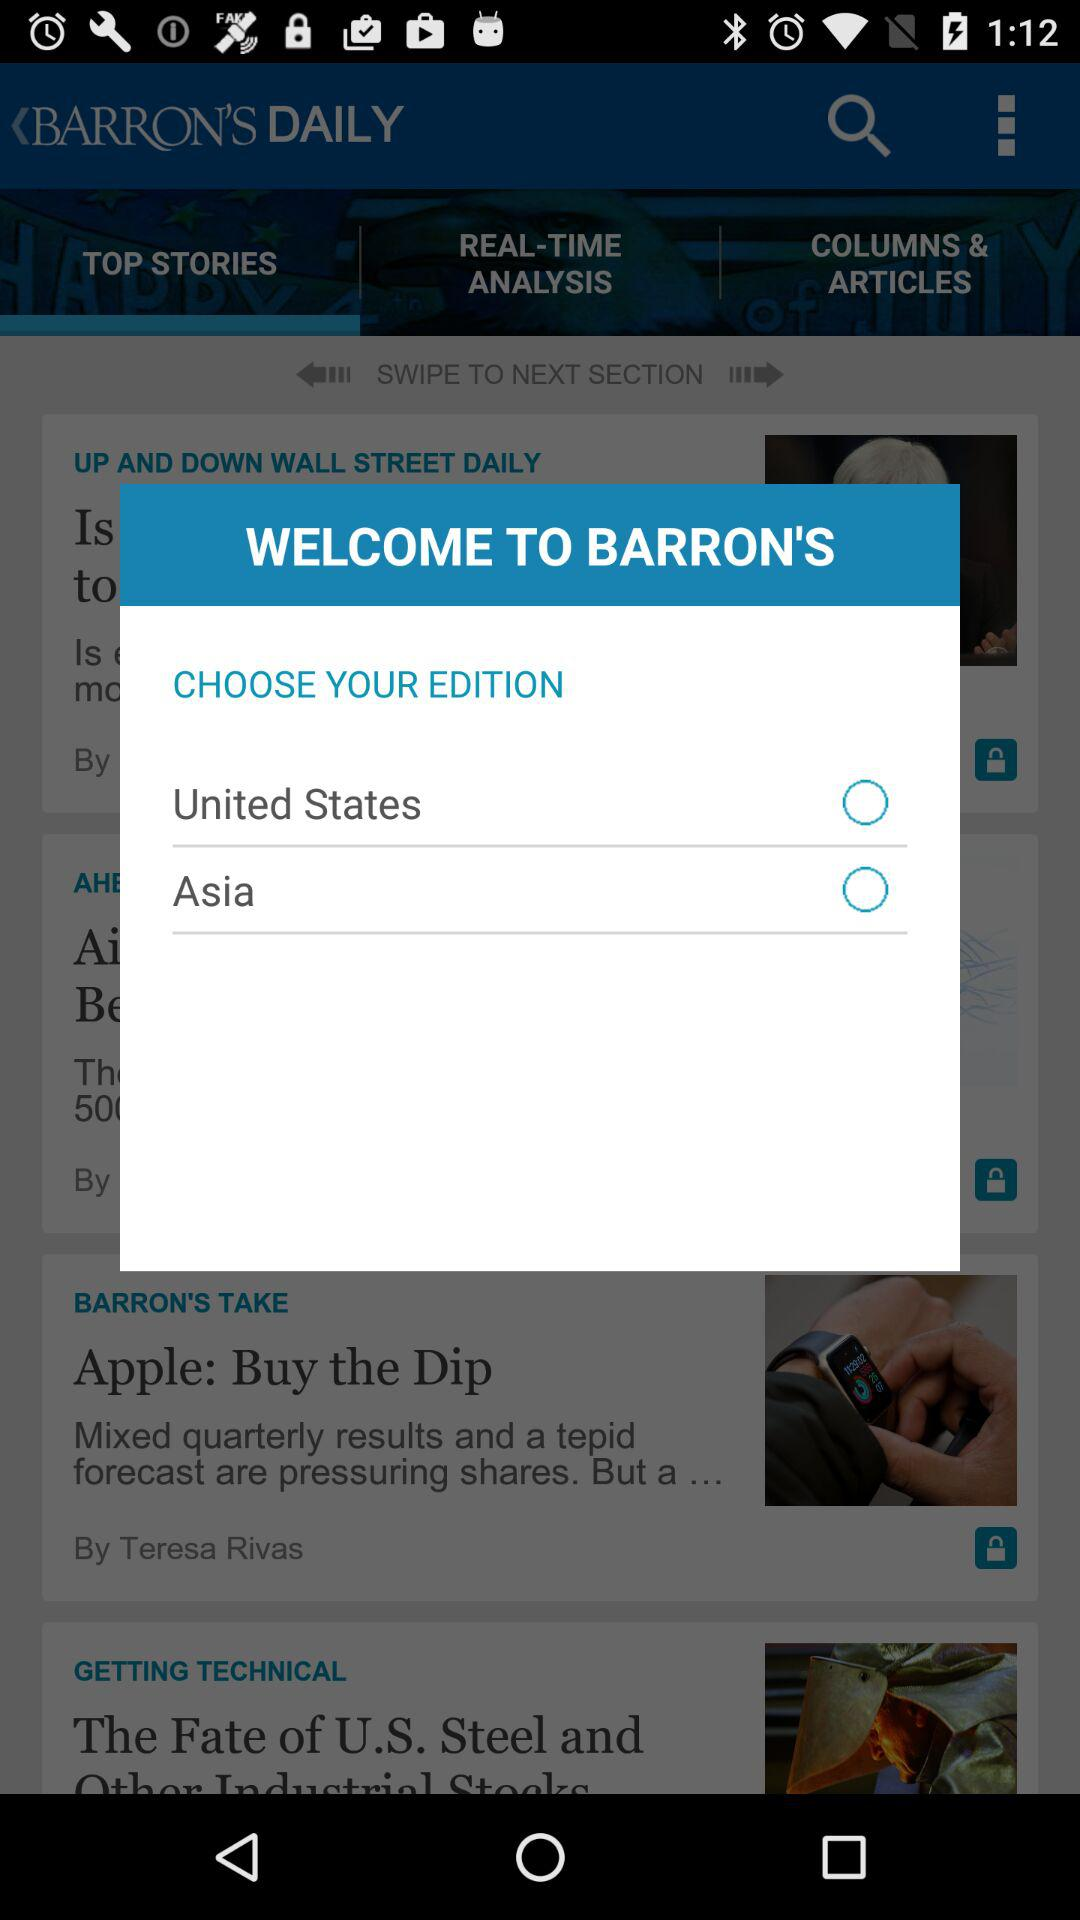Which tab is selected? The selected tab is "TOP STORIES". 